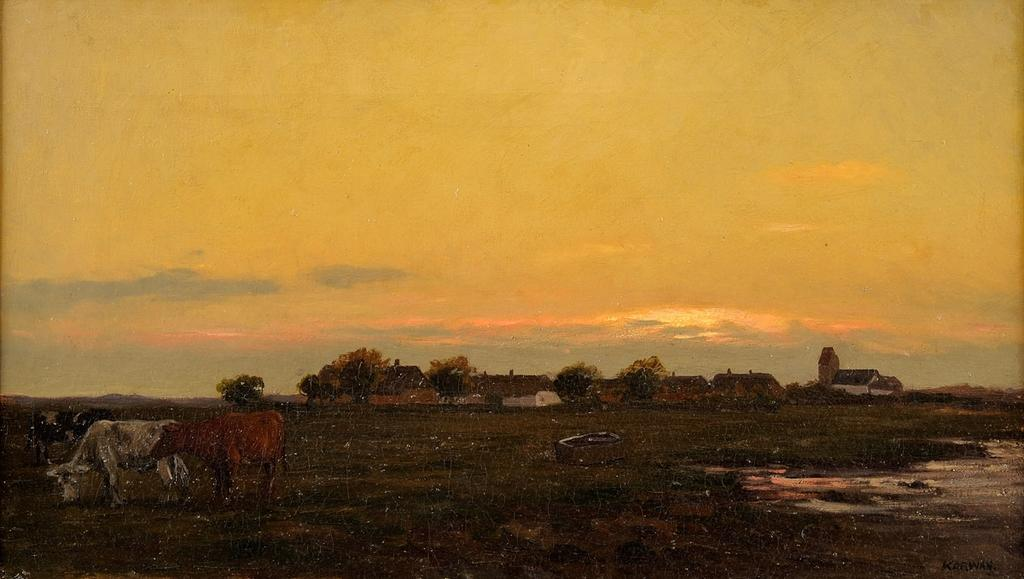What types of living organisms are present in the image? There are animals in the image. What natural elements can be seen in the image? There are trees in the image. What man-made structures are visible in the image? There are houses in the image. Can you describe the object in the image? The object in the image is not specified, but it is mentioned that it exists. What is visible at the top of the image? The sky is visible at the top of the image. What is visible at the bottom of the image? The ground and water are visible at the bottom of the image. How many brass instruments are being played by the boy in the image? There is no boy or brass instruments present in the image. What type of umbrella is being used by the animals in the image? There are no umbrellas present in the image, and the animals are not using any umbrellas. 